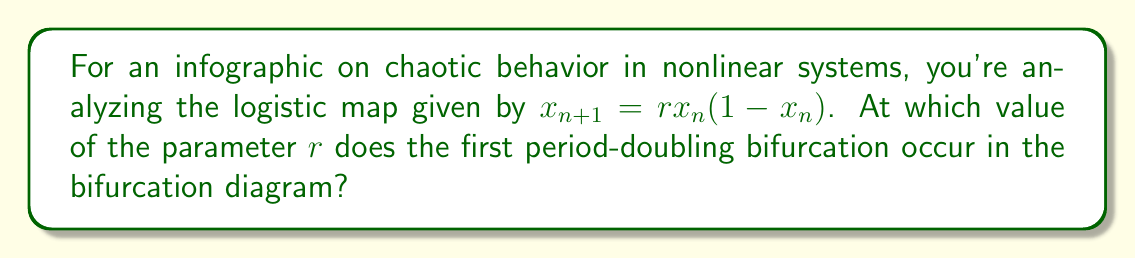What is the answer to this math problem? To find the first period-doubling bifurcation in the logistic map, we need to follow these steps:

1) The logistic map is given by the equation:
   $$x_{n+1} = rx_n(1-x_n)$$

2) For small values of $r$, the system converges to a single fixed point. We need to find when this fixed point becomes unstable.

3) A fixed point $x^*$ satisfies:
   $$x^* = rx^*(1-x^*)$$

4) Solving this equation (excluding the trivial solution $x^*=0$), we get:
   $$x^* = 1 - \frac{1}{r}$$

5) To determine stability, we calculate the derivative of the map at the fixed point:
   $$f'(x) = r(1-2x)$$
   $$f'(x^*) = r(1-2(1-\frac{1}{r})) = 2-r$$

6) The fixed point becomes unstable when $|f'(x^*)| > 1$. So we solve:
   $$|2-r| = 1$$

7) This gives us two solutions: $r=1$ or $r=3$. The solution $r=1$ is when the non-zero fixed point appears, and $r=3$ is when it becomes unstable.

8) At $r=3$, the system transitions from a single fixed point to an oscillation between two values, which is the first period-doubling bifurcation.
Answer: $r = 3$ 